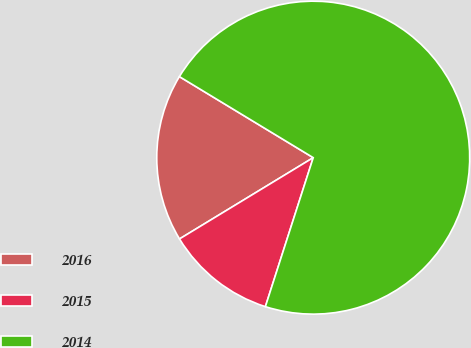<chart> <loc_0><loc_0><loc_500><loc_500><pie_chart><fcel>2016<fcel>2015<fcel>2014<nl><fcel>17.36%<fcel>11.36%<fcel>71.28%<nl></chart> 